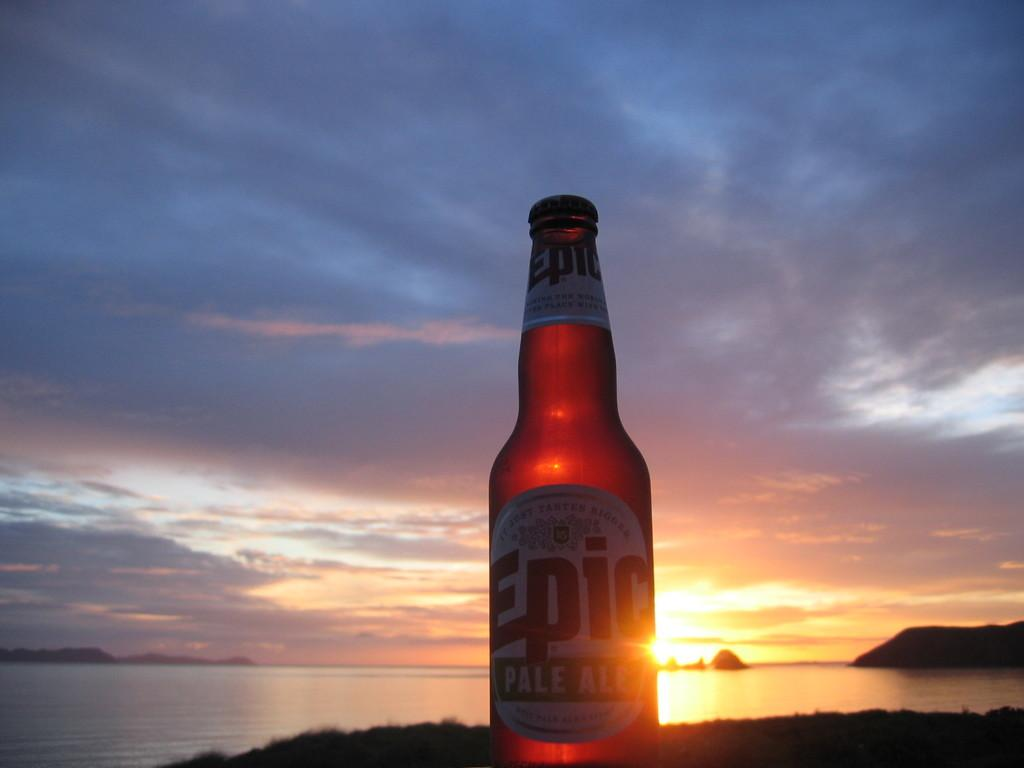<image>
Present a compact description of the photo's key features. An unopened bottle of Epic pale ale next to a body of water with the sun shining through it. 